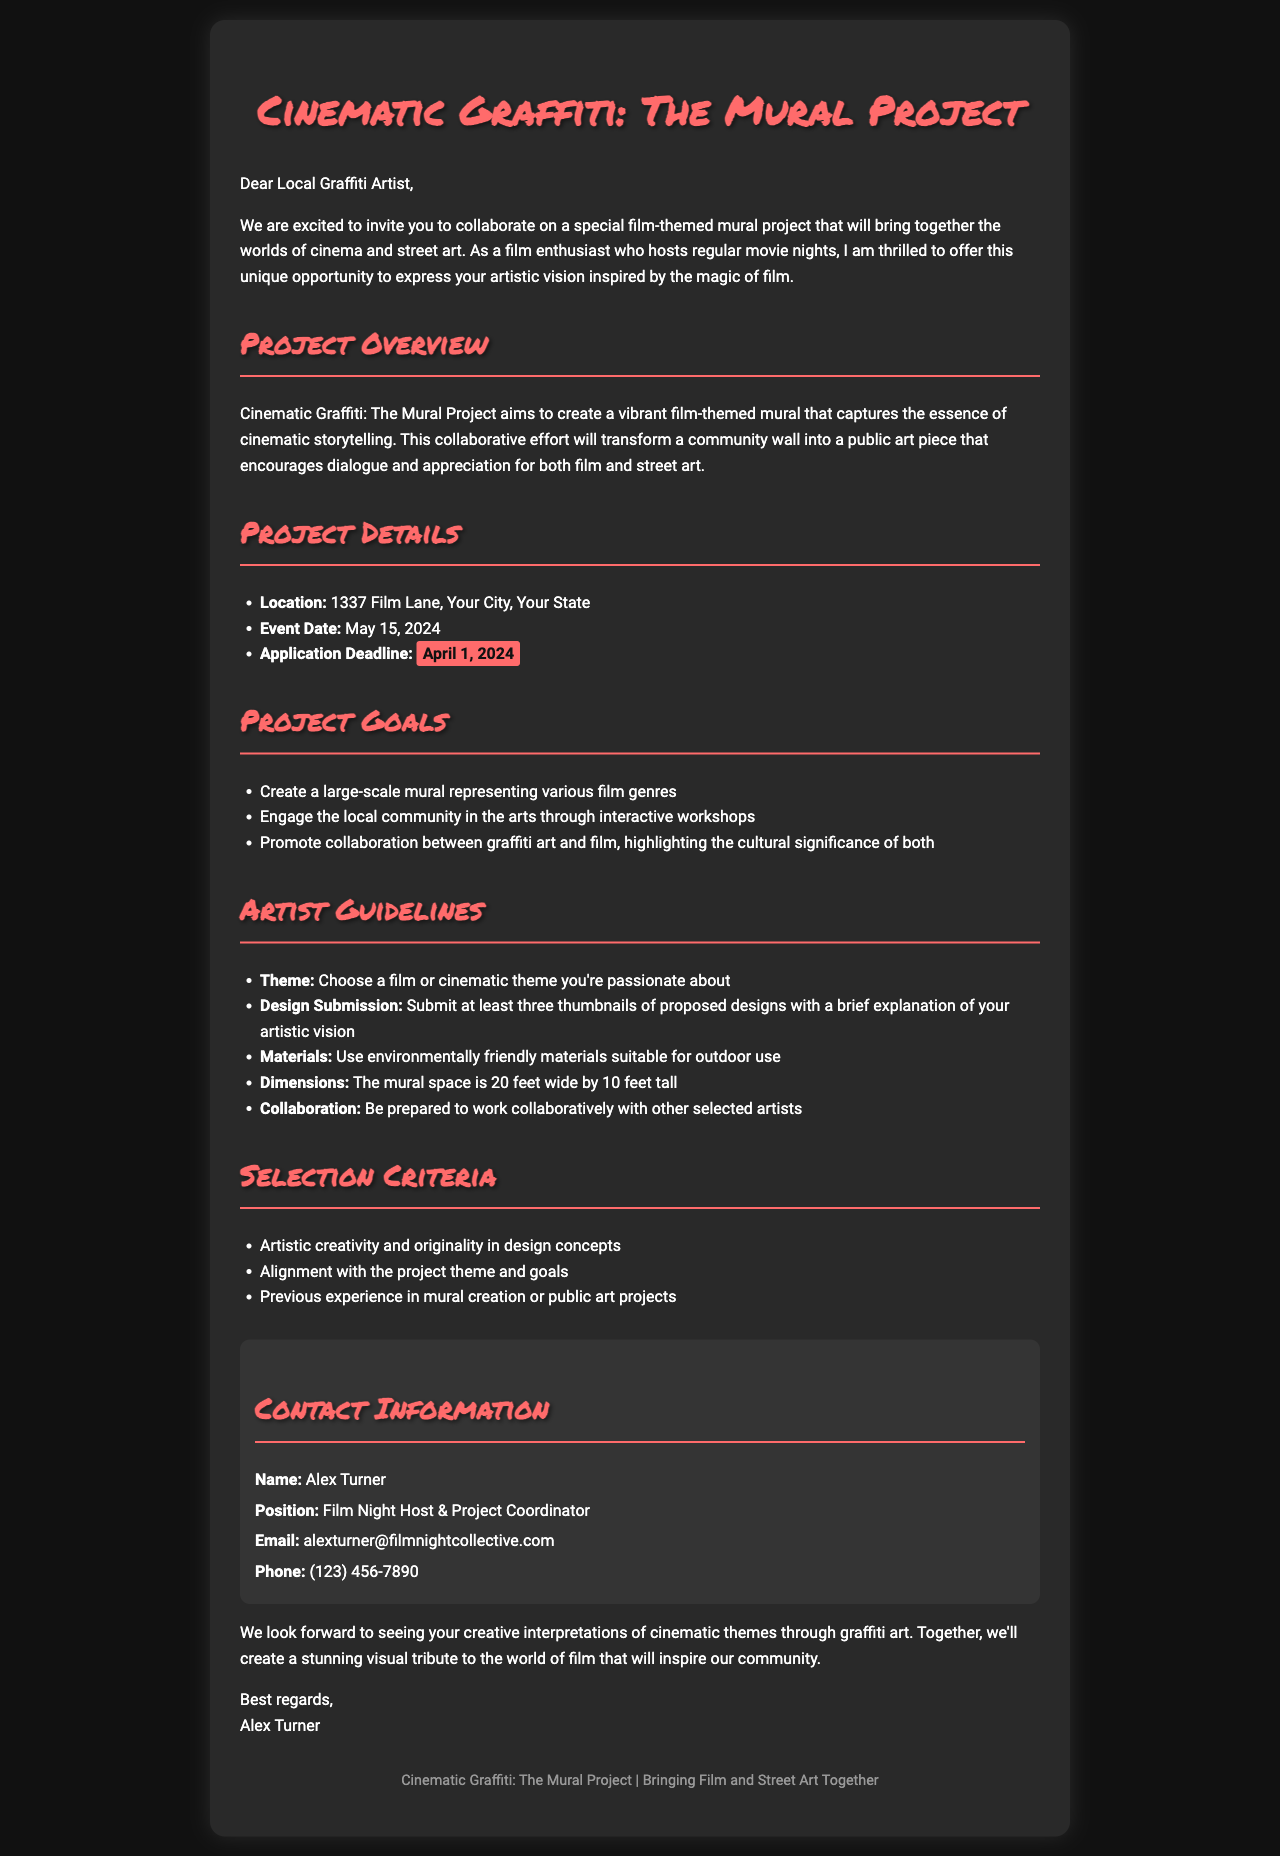What is the project title? The title of the project is prominently displayed in the heading of the document.
Answer: Cinematic Graffiti: The Mural Project When is the application deadline? The application deadline is specified in the Project Details section.
Answer: April 1, 2024 Who is the project coordinator? The name of the project coordinator is mentioned in the contact information section.
Answer: Alex Turner What size is the mural space? The dimensions of the mural space are listed under the Artist Guidelines section.
Answer: 20 feet wide by 10 feet tall What is one goal of the project? The goals of the project are outlined in the Project Goals section with several bullet points.
Answer: Create a large-scale mural representing various film genres Which materials should artists use? The materials required for the project are specified in the Artist Guidelines section.
Answer: Environmentally friendly materials suitable for outdoor use Where will the mural be located? The location is clearly mentioned in the Project Details section of the document.
Answer: 1337 Film Lane, Your City, Your State How many thumbnail designs must artists submit? The submission requirements for artists are outlined in the Artist Guidelines section.
Answer: At least three thumbnails What is the main theme of the mural project? The theme is described in the Project Overview and Guidelines sections.
Answer: Film-themed 